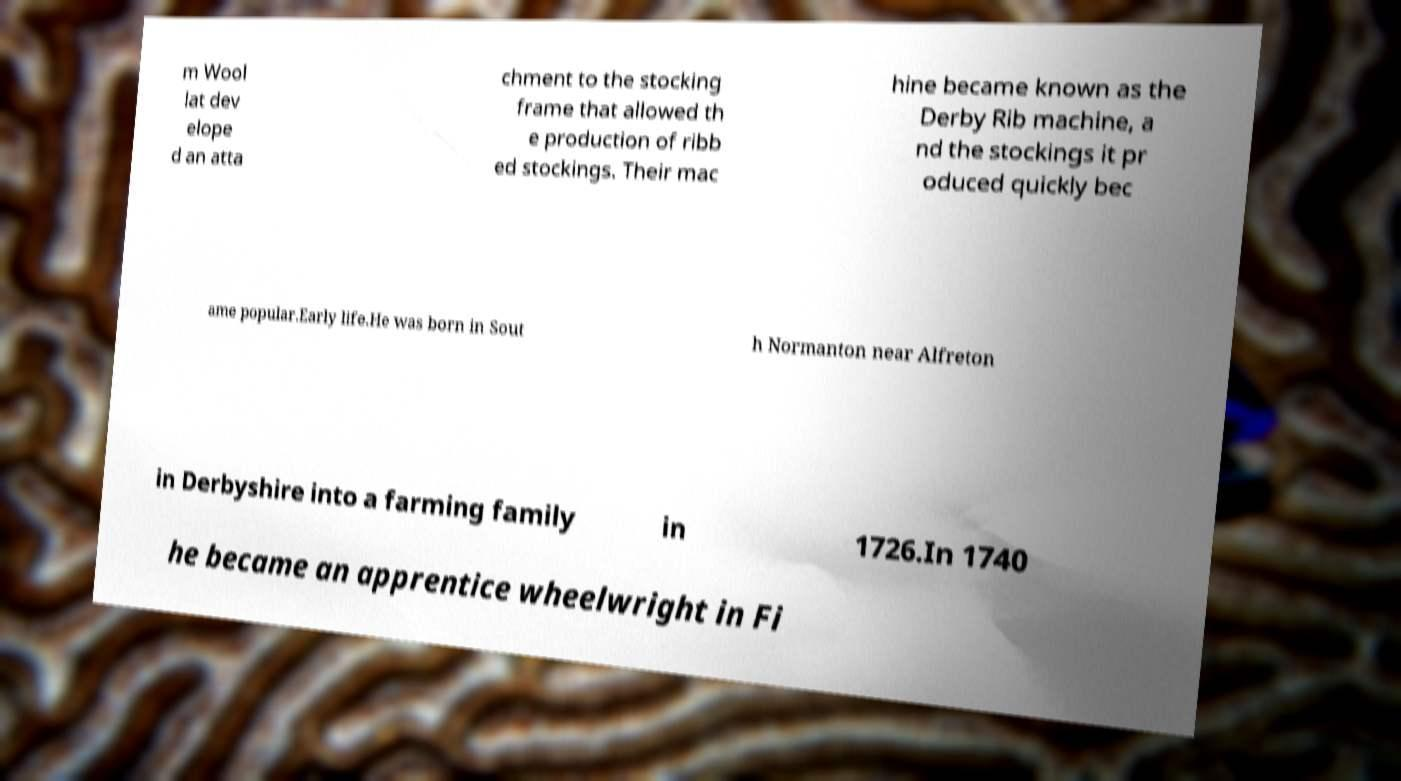For documentation purposes, I need the text within this image transcribed. Could you provide that? m Wool lat dev elope d an atta chment to the stocking frame that allowed th e production of ribb ed stockings. Their mac hine became known as the Derby Rib machine, a nd the stockings it pr oduced quickly bec ame popular.Early life.He was born in Sout h Normanton near Alfreton in Derbyshire into a farming family in 1726.In 1740 he became an apprentice wheelwright in Fi 